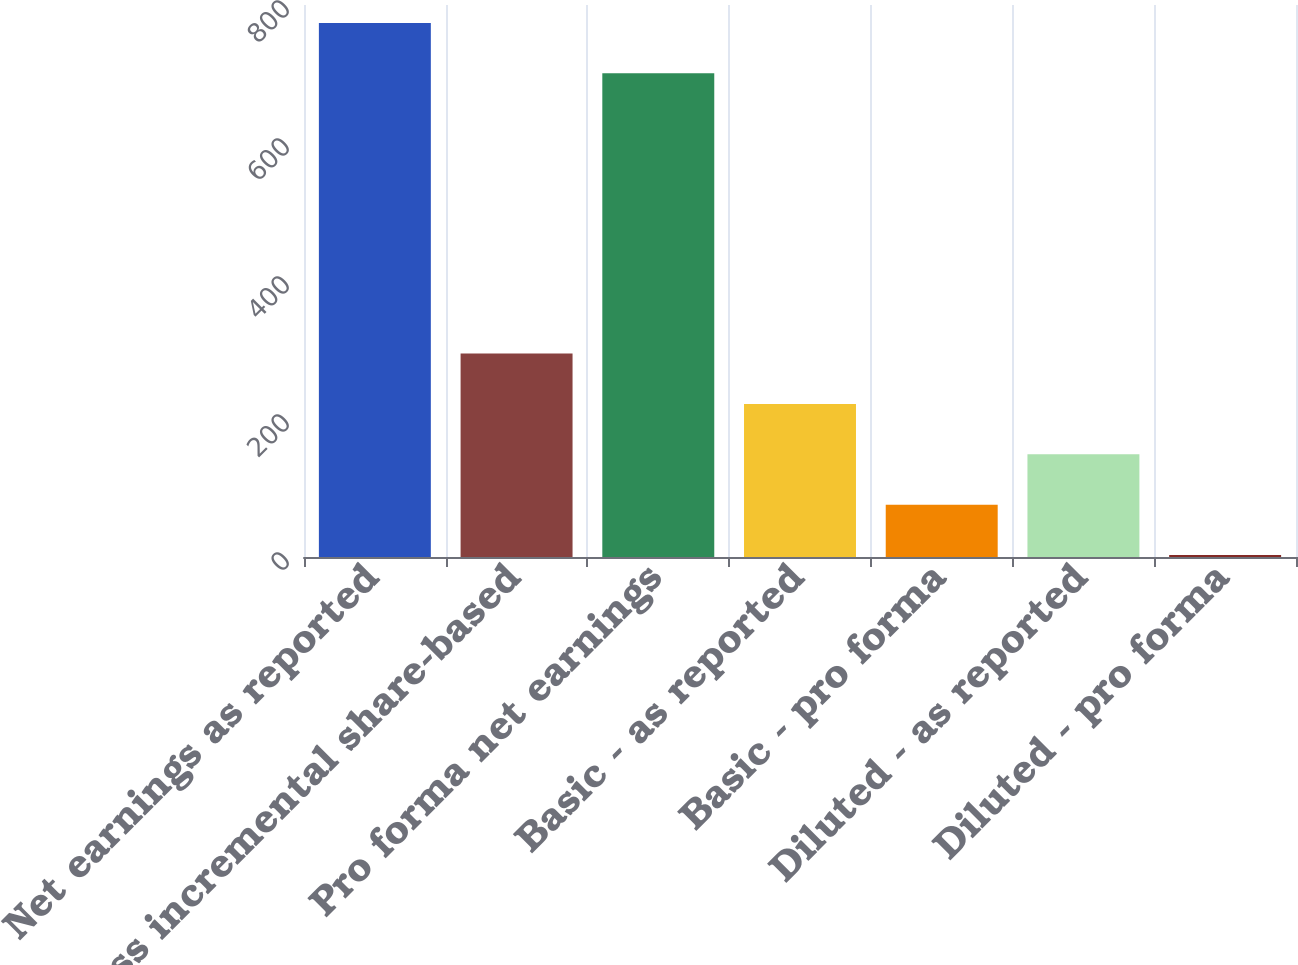<chart> <loc_0><loc_0><loc_500><loc_500><bar_chart><fcel>Net earnings as reported<fcel>Less incremental share-based<fcel>Pro forma net earnings<fcel>Basic - as reported<fcel>Basic - pro forma<fcel>Diluted - as reported<fcel>Diluted - pro forma<nl><fcel>774.01<fcel>294.9<fcel>701<fcel>221.89<fcel>75.86<fcel>148.88<fcel>2.85<nl></chart> 